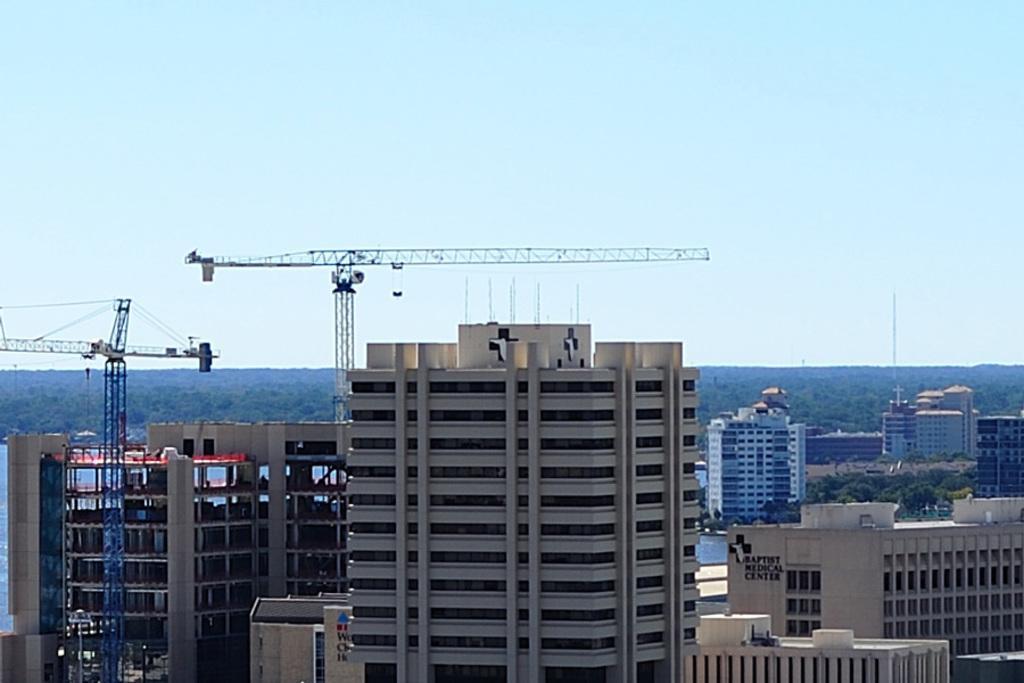Could you give a brief overview of what you see in this image? In this image, there is an outside view. In the foreground, there are some buildings. There are cranes on the left side of the image. In the background, there is a sky. 